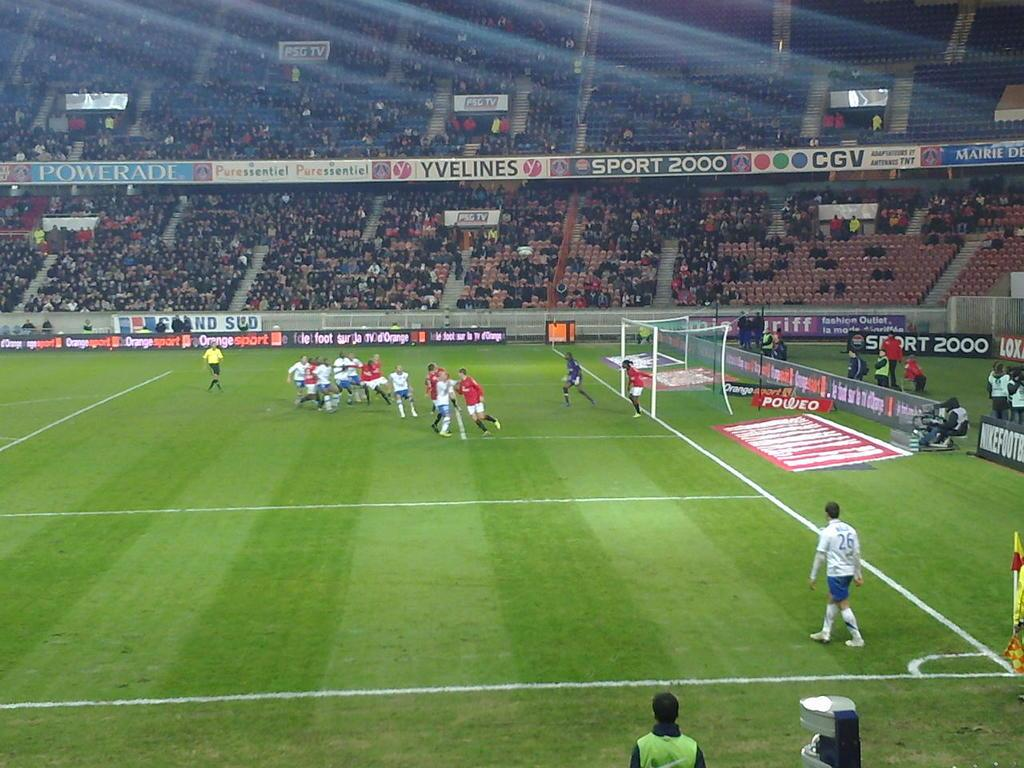Provide a one-sentence caption for the provided image. A soccer stadium with varied ads from companies like Orange Sport displayed on the stands is hosting a game. 